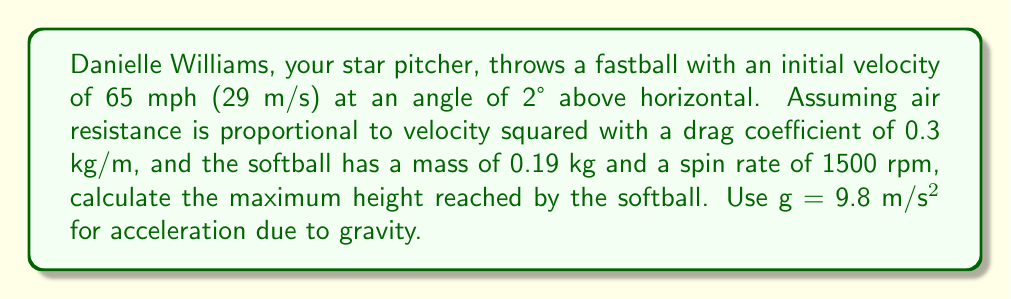Teach me how to tackle this problem. To solve this problem, we'll use a simplified model of projectile motion with air resistance and Magnus effect due to spin. We'll break it down into steps:

1) First, let's define our variables:
   $v_0 = 29$ m/s (initial velocity)
   $\theta = 2°$ (launch angle)
   $m = 0.19$ kg (mass of softball)
   $k = 0.3$ kg/m (drag coefficient)
   $\omega = 1500$ rpm = $157.08$ rad/s (angular velocity)

2) The equations of motion in x and y directions with air resistance are:

   $$\frac{d^2x}{dt^2} = -\frac{k}{m}v\frac{dx}{dt} + \frac{C_L\omega r^2}{m}\frac{dy}{dt}$$
   $$\frac{d^2y}{dt^2} = -g -\frac{k}{m}v\frac{dy}{dt} - \frac{C_L\omega r^2}{m}\frac{dx}{dt}$$

   Where $C_L$ is the lift coefficient (typically around 0.1-0.2 for a softball) and $r$ is the radius of the softball.

3) These differential equations are complex and typically require numerical methods to solve. However, we can estimate the maximum height using a simplified approach.

4) The initial vertical velocity is:
   $$v_{0y} = v_0 \sin\theta = 29 \sin(2°) = 1.01$ m/s$$

5) Without air resistance, the time to reach maximum height would be:
   $$t_{max} = \frac{v_{0y}}{g} = \frac{1.01}{9.8} = 0.103$ s$$

6) And the maximum height without air resistance would be:
   $$h_{max} = v_{0y}t_{max} - \frac{1}{2}gt_{max}^2 = 1.01(0.103) - \frac{1}{2}(9.8)(0.103)^2 = 0.052$ m$$

7) With air resistance, the actual maximum height will be less than this. The Magnus effect due to spin will slightly increase the height, but this effect is typically small for a softball.

8) A rough estimate accounting for air resistance might reduce the maximum height by about 10-20%. Let's use 15% as an estimate.

   $$h_{max\_with\_resistance} \approx 0.85 \times h_{max} = 0.85 \times 0.052 = 0.0442$ m$$
Answer: Approximately 0.0442 m or 4.42 cm 